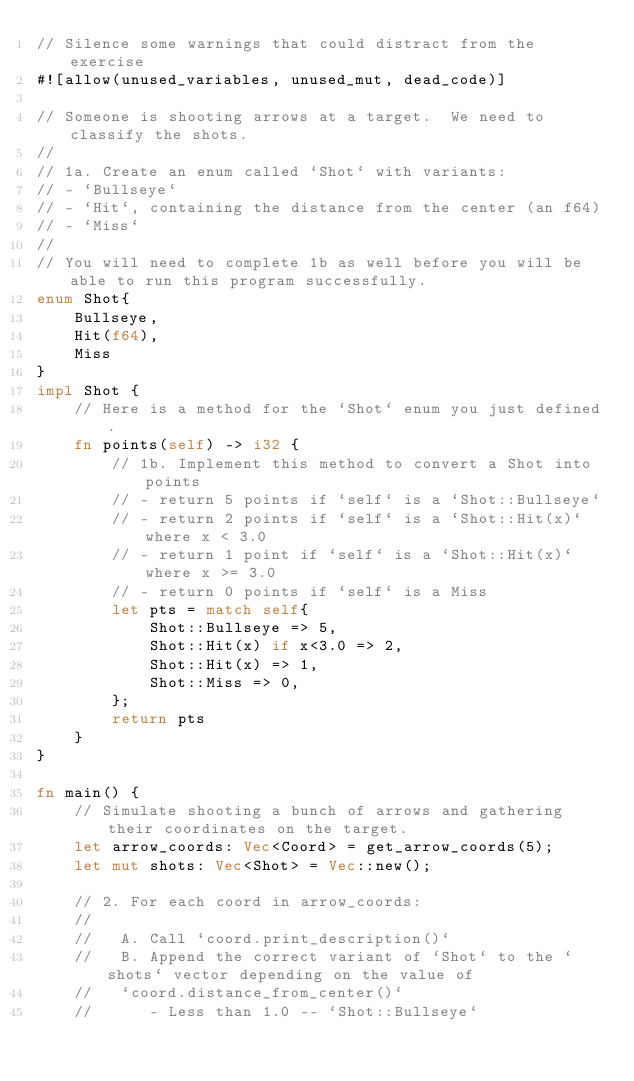Convert code to text. <code><loc_0><loc_0><loc_500><loc_500><_Rust_>// Silence some warnings that could distract from the exercise
#![allow(unused_variables, unused_mut, dead_code)]

// Someone is shooting arrows at a target.  We need to classify the shots.
//
// 1a. Create an enum called `Shot` with variants:
// - `Bullseye`
// - `Hit`, containing the distance from the center (an f64)
// - `Miss`
//
// You will need to complete 1b as well before you will be able to run this program successfully.
enum Shot{
    Bullseye,
    Hit(f64),
    Miss
}
impl Shot {
    // Here is a method for the `Shot` enum you just defined.
    fn points(self) -> i32 {
        // 1b. Implement this method to convert a Shot into points
        // - return 5 points if `self` is a `Shot::Bullseye`
        // - return 2 points if `self` is a `Shot::Hit(x)` where x < 3.0
        // - return 1 point if `self` is a `Shot::Hit(x)` where x >= 3.0
        // - return 0 points if `self` is a Miss
        let pts = match self{
            Shot::Bullseye => 5,
            Shot::Hit(x) if x<3.0 => 2,
            Shot::Hit(x) => 1,
            Shot::Miss => 0,
        };
        return pts
    }
}

fn main() {
    // Simulate shooting a bunch of arrows and gathering their coordinates on the target.
    let arrow_coords: Vec<Coord> = get_arrow_coords(5);
    let mut shots: Vec<Shot> = Vec::new();

    // 2. For each coord in arrow_coords:
    //
    //   A. Call `coord.print_description()`
    //   B. Append the correct variant of `Shot` to the `shots` vector depending on the value of
    //   `coord.distance_from_center()`
    //      - Less than 1.0 -- `Shot::Bullseye`</code> 